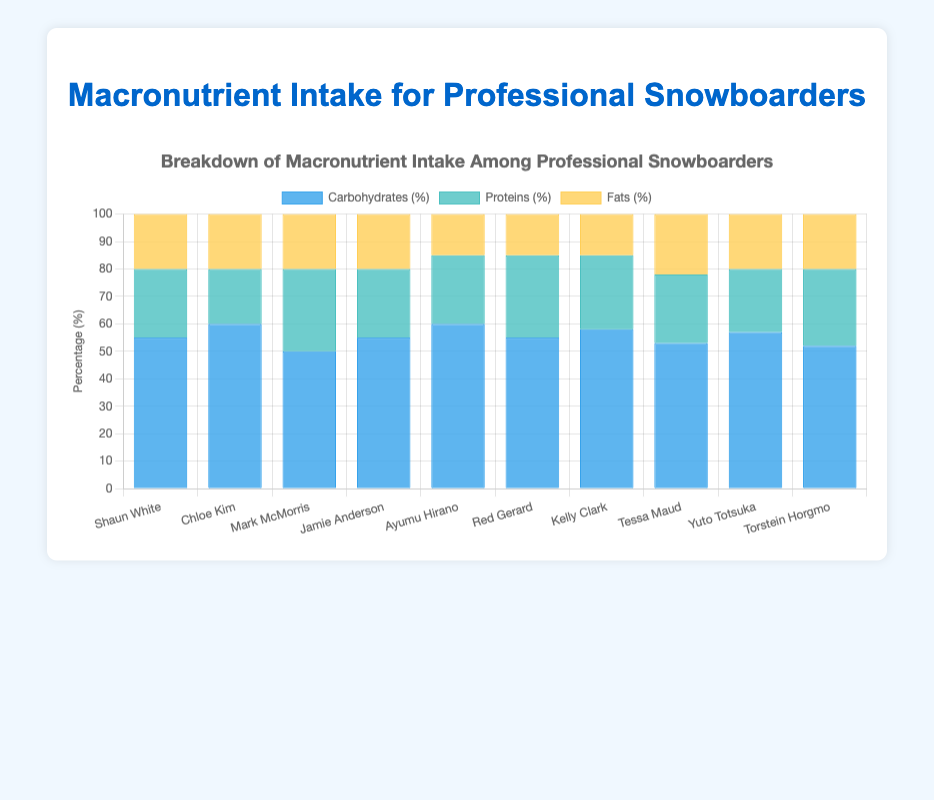Which snowboarder has the highest carbohydrate intake percentage? The figure shows the breakdown of macronutrient intake for each snowboarder. Chloe Kim and Ayumu Hirano both have the highest carbohydrate intake at 60%.
Answer: Chloe Kim and Ayumu Hirano What is the difference in protein intake between Mark McMorris and Yuto Totsuka? Mark McMorris has a protein intake of 30%, and Yuto Totsuka has a protein intake of 23%. The difference is 30% - 23% = 7%.
Answer: 7% Which snowboarders have an equal percentage of fat intake? By examining the bar lengths associated with fat intake, it is observed that several snowboarders have the same percentage of fat intake. Shaun White, Chloe Kim, Mark McMorris, Jamie Anderson, Tessa Maud, Yuto Totsuka, and Torstein Horgmo all have 20% fat intake.
Answer: Shaun White, Chloe Kim, Mark McMorris, Jamie Anderson, Tessa Maud, Yuto Totsuka, Torstein Horgmo What is the average percentage of carbohydrate intake across all snowboarders? The carbohydrate intake percentages are 55, 60, 50, 55, 60, 55, 58, 53, 57, and 52. Adding these gives 555. Dividing by 10 (the number of snowboarders) gives an average of 555/10 = 55.5%.
Answer: 55.5% By how much does Kelly Clark’s protein intake exceed Chloe Kim’s protein intake? Kelly Clark's protein intake is 27% and Chloe Kim's is 20%. The difference is 27% - 20% = 7%.
Answer: 7% Which snowboarder has the lowest fat intake percentage, and what is that percentage? Ayumu Hirano and Red Gerard both have the lowest fat intake at 15%.
Answer: Ayumu Hirano and Red Gerard Calculate the sum of protein intakes for Shaun White, Jamie Anderson, and Red Gerard. Shaun White has 25%, Jamie Anderson has 25%, and Red Gerard has 30%. The sum is 25% + 25% + 30% = 80%.
Answer: 80% Is Tessa Maud’s carbohydrate intake higher or lower than Torstein Horgmo’s? Tessa Maud has a carbohydrate intake of 53%, while Torstein Horgmo has 52%. Tessa Maud’s intake is higher.
Answer: Higher Compare the total percentage of protein and fat intake for Yuto Totsuka. Which is higher, and by how much? Yuto Totsuka has 23% protein and 20% fat intake. The total percentage for protein and fat is 23% + 20% = 43%. Protein intake is higher than fat intake by 23% - 20% = 3%.
Answer: Protein higher by 3% 